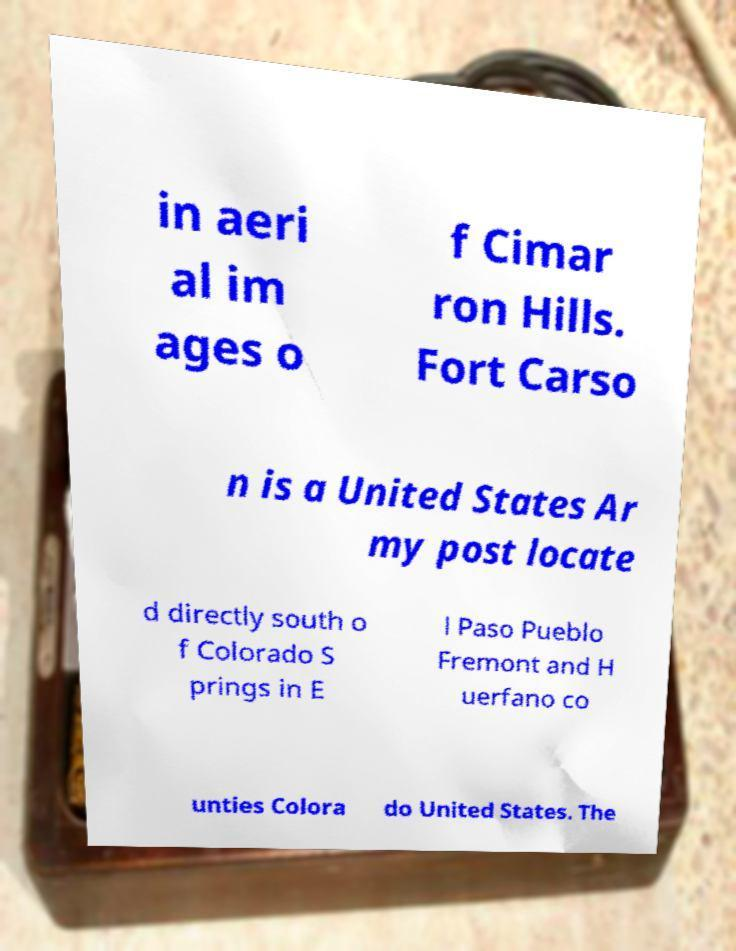Please identify and transcribe the text found in this image. in aeri al im ages o f Cimar ron Hills. Fort Carso n is a United States Ar my post locate d directly south o f Colorado S prings in E l Paso Pueblo Fremont and H uerfano co unties Colora do United States. The 